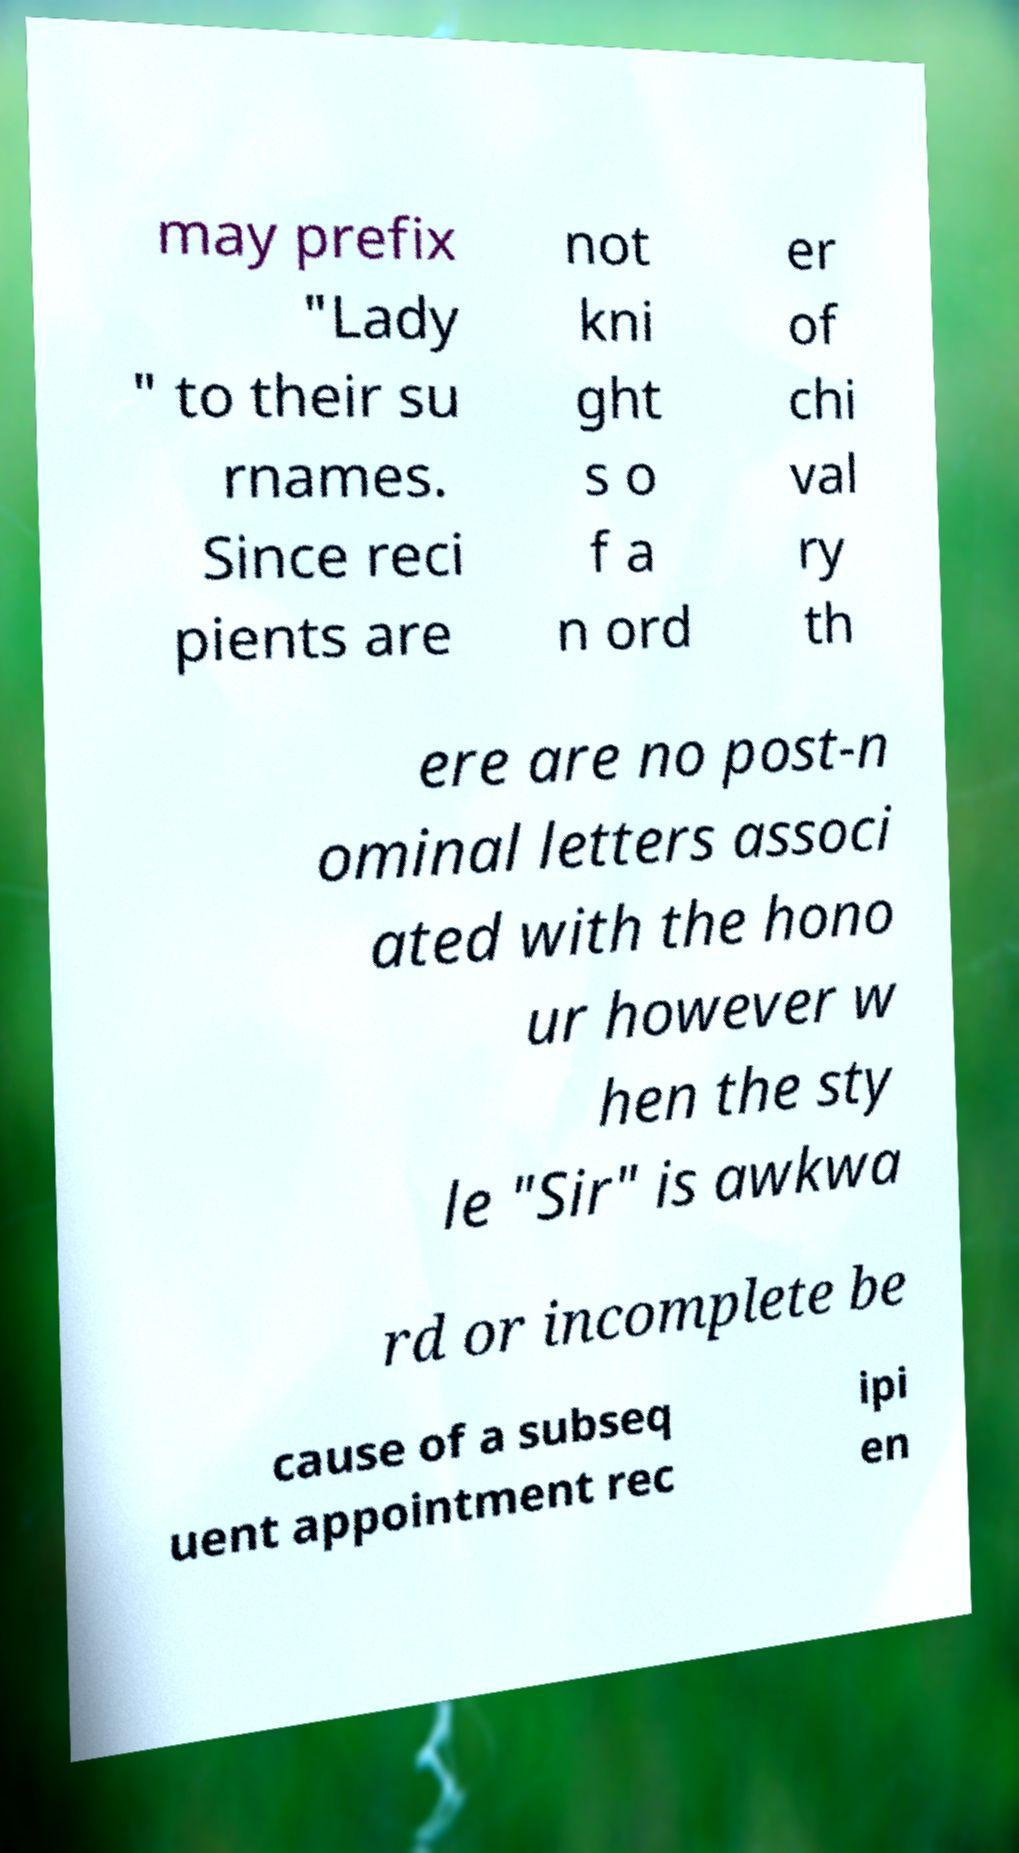Please identify and transcribe the text found in this image. may prefix "Lady " to their su rnames. Since reci pients are not kni ght s o f a n ord er of chi val ry th ere are no post-n ominal letters associ ated with the hono ur however w hen the sty le "Sir" is awkwa rd or incomplete be cause of a subseq uent appointment rec ipi en 